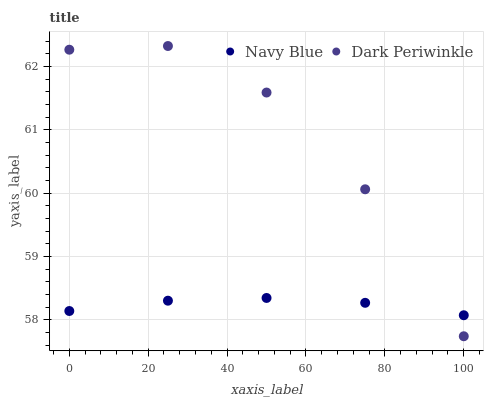Does Navy Blue have the minimum area under the curve?
Answer yes or no. Yes. Does Dark Periwinkle have the maximum area under the curve?
Answer yes or no. Yes. Does Dark Periwinkle have the minimum area under the curve?
Answer yes or no. No. Is Navy Blue the smoothest?
Answer yes or no. Yes. Is Dark Periwinkle the roughest?
Answer yes or no. Yes. Is Dark Periwinkle the smoothest?
Answer yes or no. No. Does Dark Periwinkle have the lowest value?
Answer yes or no. Yes. Does Dark Periwinkle have the highest value?
Answer yes or no. Yes. Does Dark Periwinkle intersect Navy Blue?
Answer yes or no. Yes. Is Dark Periwinkle less than Navy Blue?
Answer yes or no. No. Is Dark Periwinkle greater than Navy Blue?
Answer yes or no. No. 